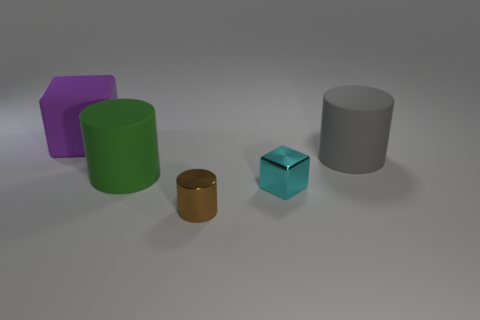Add 2 small brown cylinders. How many objects exist? 7 Subtract all cylinders. How many objects are left? 2 Subtract 0 purple cylinders. How many objects are left? 5 Subtract all cyan metallic cubes. Subtract all cyan objects. How many objects are left? 3 Add 2 big rubber cylinders. How many big rubber cylinders are left? 4 Add 1 gray metal spheres. How many gray metal spheres exist? 1 